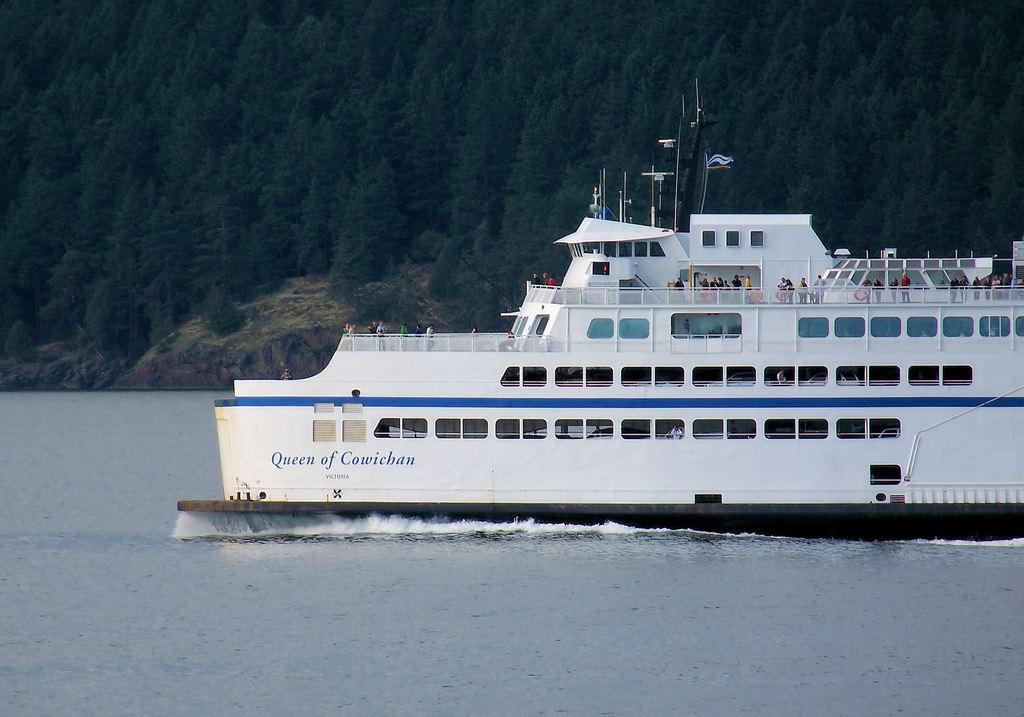What is the main subject in the foreground of the image? There is a ship in the foreground of the image. What is the ship's location in relation to the water? The ship is on the water. What can be seen in the background of the image? There are trees and a rock in the background of the image. What type of nail is being used to secure the hose to the ship in the image? There is no hose or nail present in the image; it only features a ship on the water with trees and a rock in the background. 